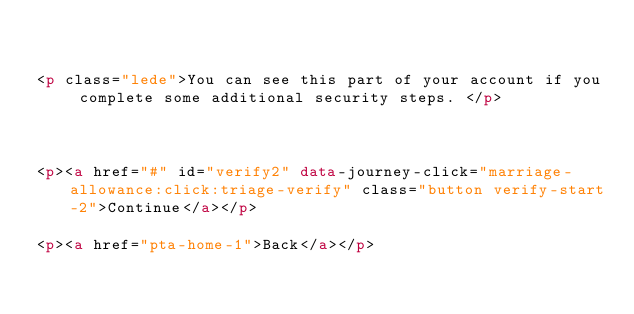<code> <loc_0><loc_0><loc_500><loc_500><_HTML_>

<p class="lede">You can see this part of your account if you complete some additional security steps. </p>



<p><a href="#" id="verify2" data-journey-click="marriage-allowance:click:triage-verify" class="button verify-start-2">Continue</a></p>

<p><a href="pta-home-1">Back</a></p>
</code> 